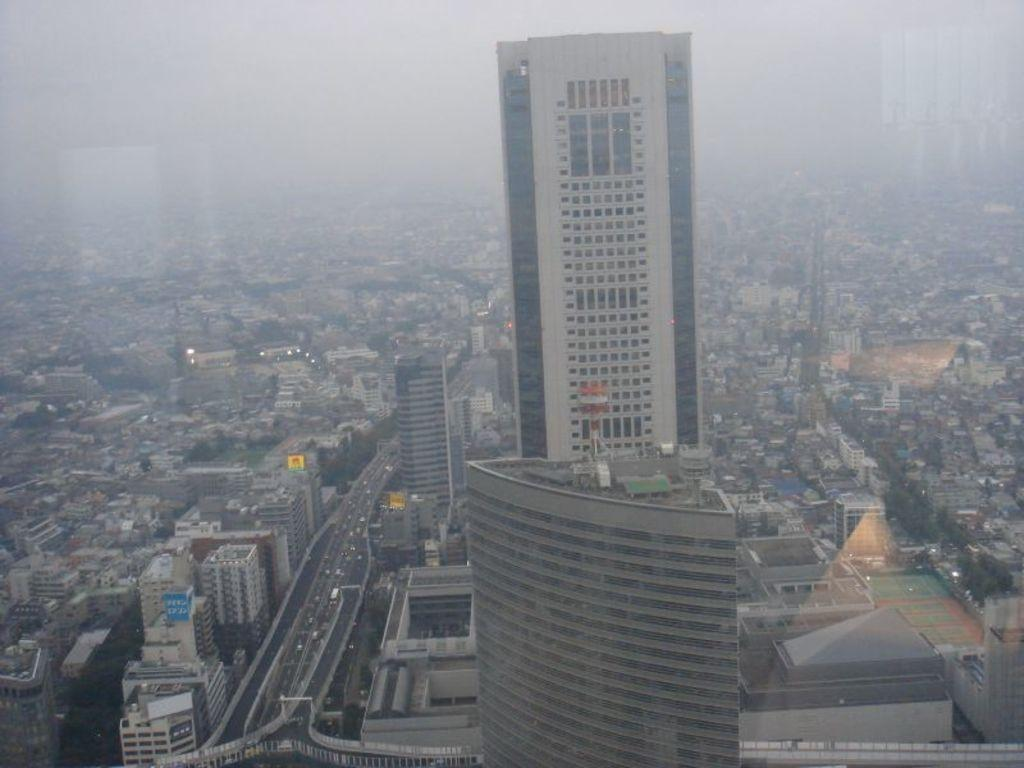What type of view is depicted in the image? The image shows an aerial view of the city. What structures can be seen in the image? There are buildings in the image. What are the roads used for in the image? There are vehicles on the roads in the image. What type of vegetation is present in the image? There are trees in the image. What are the boards used for in the image? The purpose of the boards in the image is not clear, but they could be signs or advertisements. How does the flock of birds fly over the city in the image? There are no birds visible in the image; it only shows an aerial view of the city with buildings, vehicles, trees, and boards. 